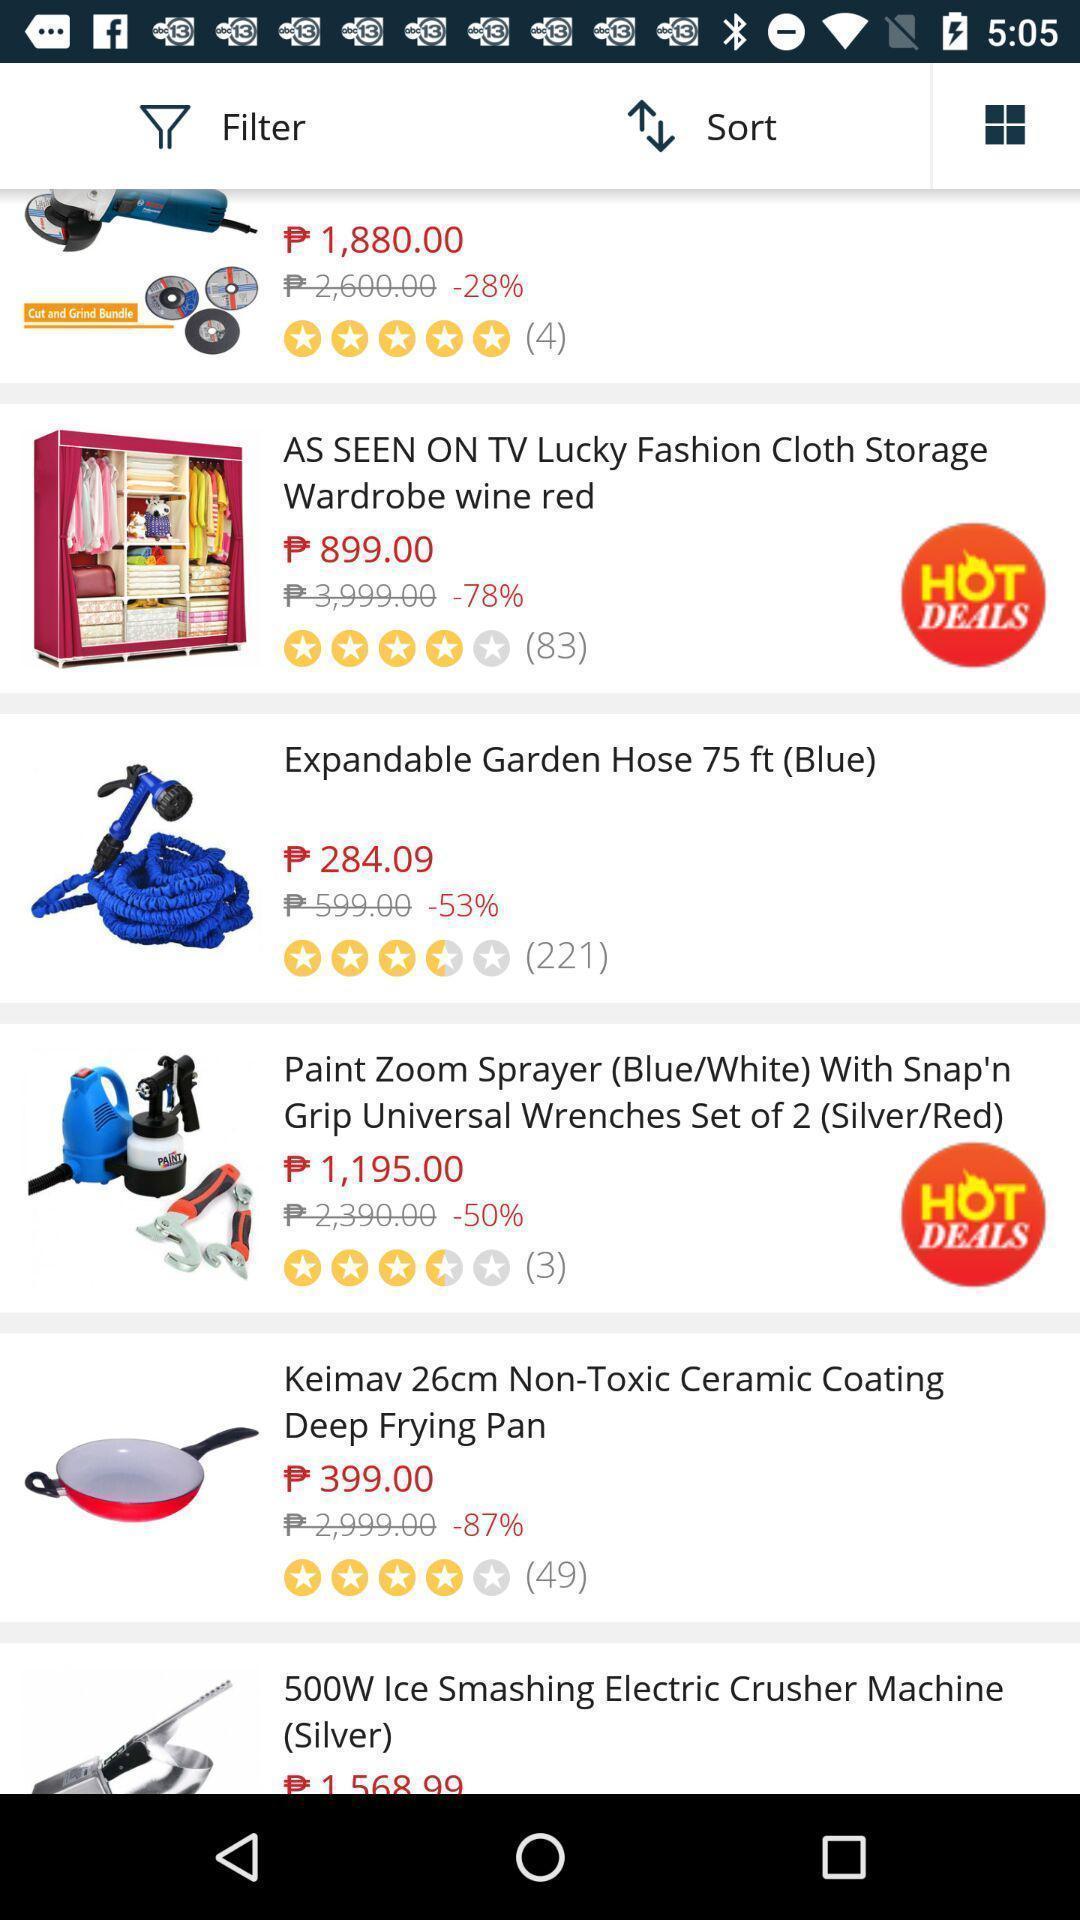What details can you identify in this image? Page displaying list of products in shopping app. 